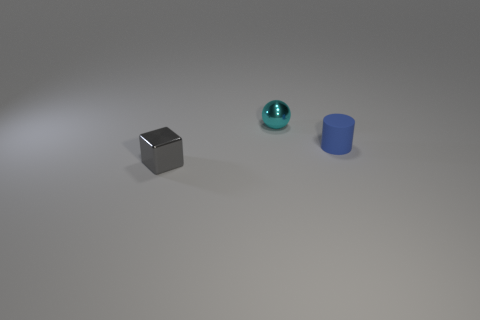Are there any other things that are the same size as the matte thing?
Your answer should be compact. Yes. Is there any other thing of the same color as the metallic sphere?
Your answer should be very brief. No. Are there more blue cylinders on the left side of the cylinder than cyan metal balls?
Provide a short and direct response. No. Do the blue matte thing and the small shiny thing that is to the left of the sphere have the same shape?
Your answer should be very brief. No. How many metallic objects are the same size as the blue rubber cylinder?
Make the answer very short. 2. There is a shiny object in front of the small shiny object that is behind the tiny block; what number of tiny objects are behind it?
Make the answer very short. 2. Are there an equal number of blue cylinders that are in front of the small blue rubber object and blocks in front of the shiny block?
Provide a short and direct response. Yes. How many other rubber objects have the same shape as the small cyan object?
Your answer should be very brief. 0. Are there any blue objects that have the same material as the small cylinder?
Your response must be concise. No. How many small blue objects are there?
Keep it short and to the point. 1. 